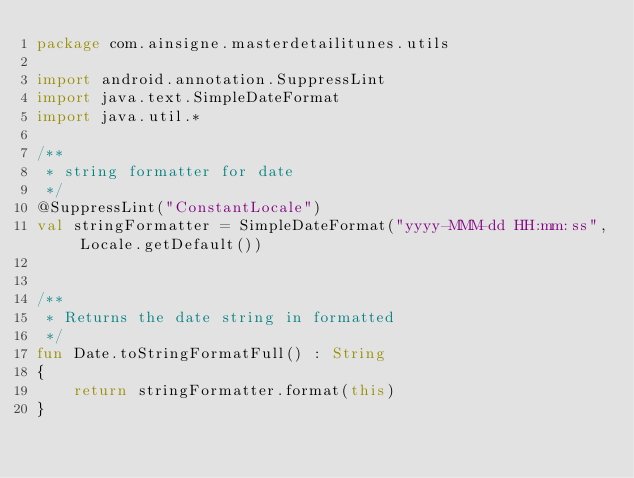Convert code to text. <code><loc_0><loc_0><loc_500><loc_500><_Kotlin_>package com.ainsigne.masterdetailitunes.utils

import android.annotation.SuppressLint
import java.text.SimpleDateFormat
import java.util.*

/**
 * string formatter for date
 */
@SuppressLint("ConstantLocale")
val stringFormatter = SimpleDateFormat("yyyy-MMM-dd HH:mm:ss", Locale.getDefault())


/**
 * Returns the date string in formatted
 */
fun Date.toStringFormatFull() : String
{
    return stringFormatter.format(this)
}

</code> 